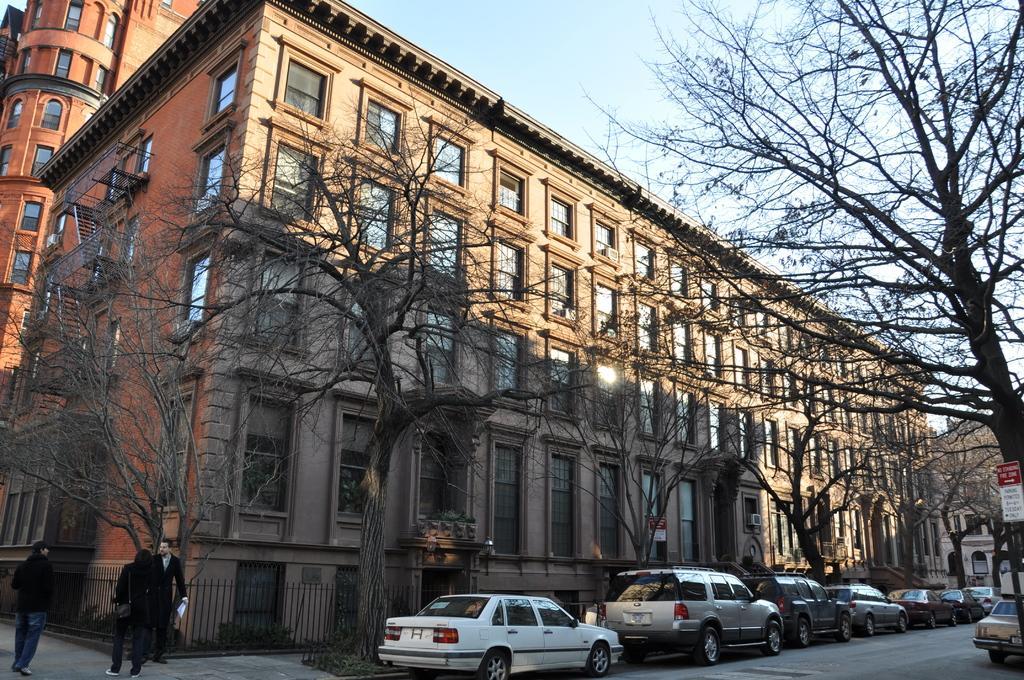How would you summarize this image in a sentence or two? In this image there are three persons standing , vehicles parked on the path, iron grills, board, trees, buildings, and in the background there is sky. 